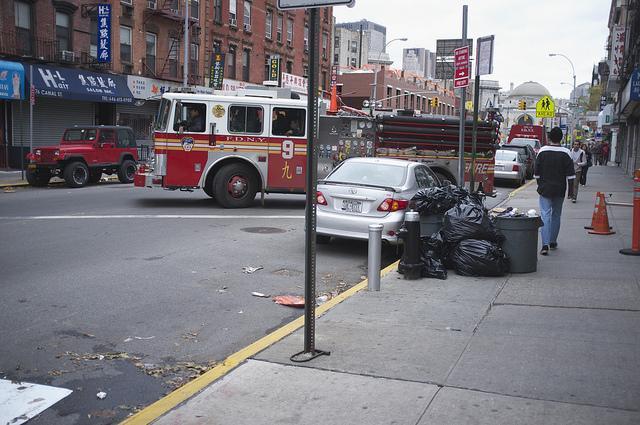How many cars are visible?
Give a very brief answer. 2. 